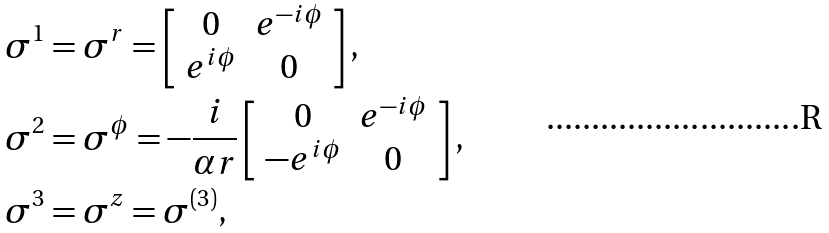<formula> <loc_0><loc_0><loc_500><loc_500>\sigma ^ { 1 } & = \sigma ^ { r } = \left [ \begin{array} { c c } 0 & e ^ { - i \phi } \\ e ^ { i \phi } & 0 \end{array} \right ] , \\ \sigma ^ { 2 } & = \sigma ^ { \phi } = - \frac { i } { \alpha r } \left [ \begin{array} { c c } 0 & e ^ { - i \phi } \\ - e ^ { i \phi } & 0 \end{array} \right ] , \\ \sigma ^ { 3 } & = \sigma ^ { z } = \sigma ^ { ( 3 ) } ,</formula> 